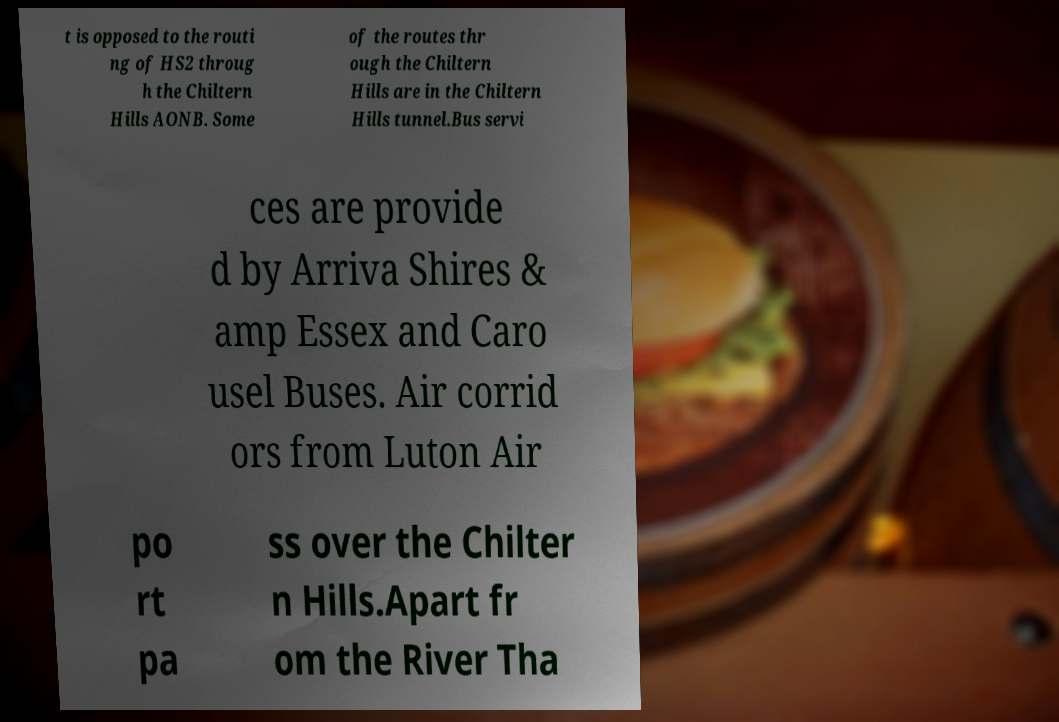Please read and relay the text visible in this image. What does it say? t is opposed to the routi ng of HS2 throug h the Chiltern Hills AONB. Some of the routes thr ough the Chiltern Hills are in the Chiltern Hills tunnel.Bus servi ces are provide d by Arriva Shires & amp Essex and Caro usel Buses. Air corrid ors from Luton Air po rt pa ss over the Chilter n Hills.Apart fr om the River Tha 